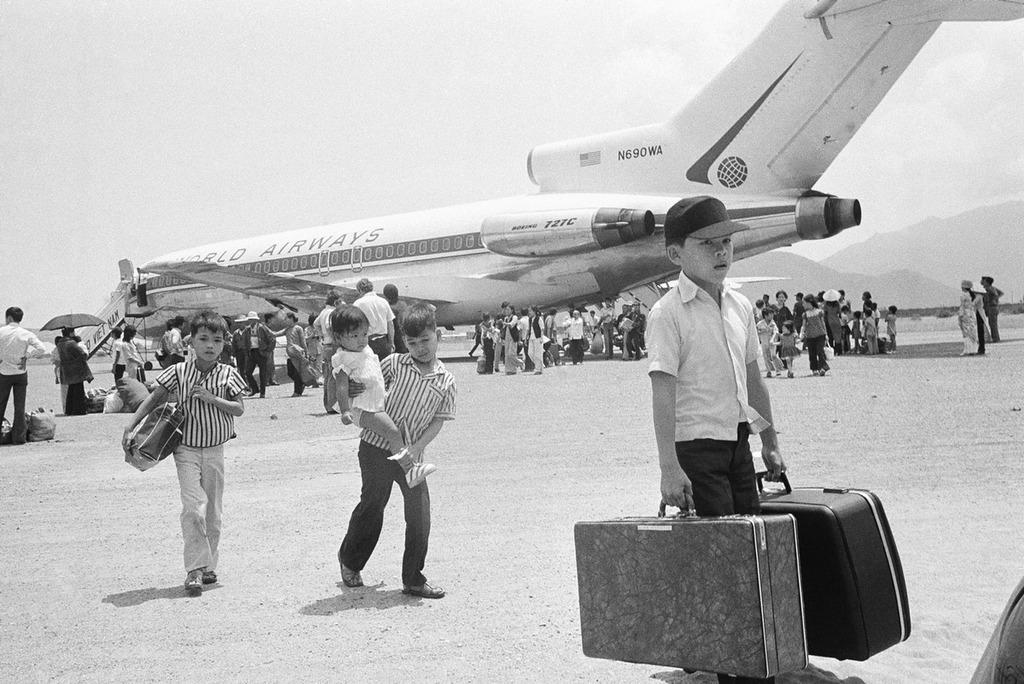How many people are in the group visible in the image? There is a group of people in the image, but the exact number is not specified. What are the people near in the image? The group of people is standing near an airplane. What can be seen in the background of the image? There is a sky and mountains visible in the background of the image. What type of stamp can be seen on the eye of the person in the image? There is no stamp visible on anyone's eye in the image. What is the name of the person standing closest to the airplane? The names of the people in the image are not mentioned, so it cannot be determined. 